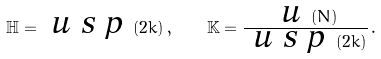<formula> <loc_0><loc_0><loc_500><loc_500>\mathbb { H } = \emph { u s p } ( 2 k ) \, , \quad \mathbb { K } = \frac { \emph { u } ( N ) } { \emph { u s p } ( 2 k ) } \, .</formula> 